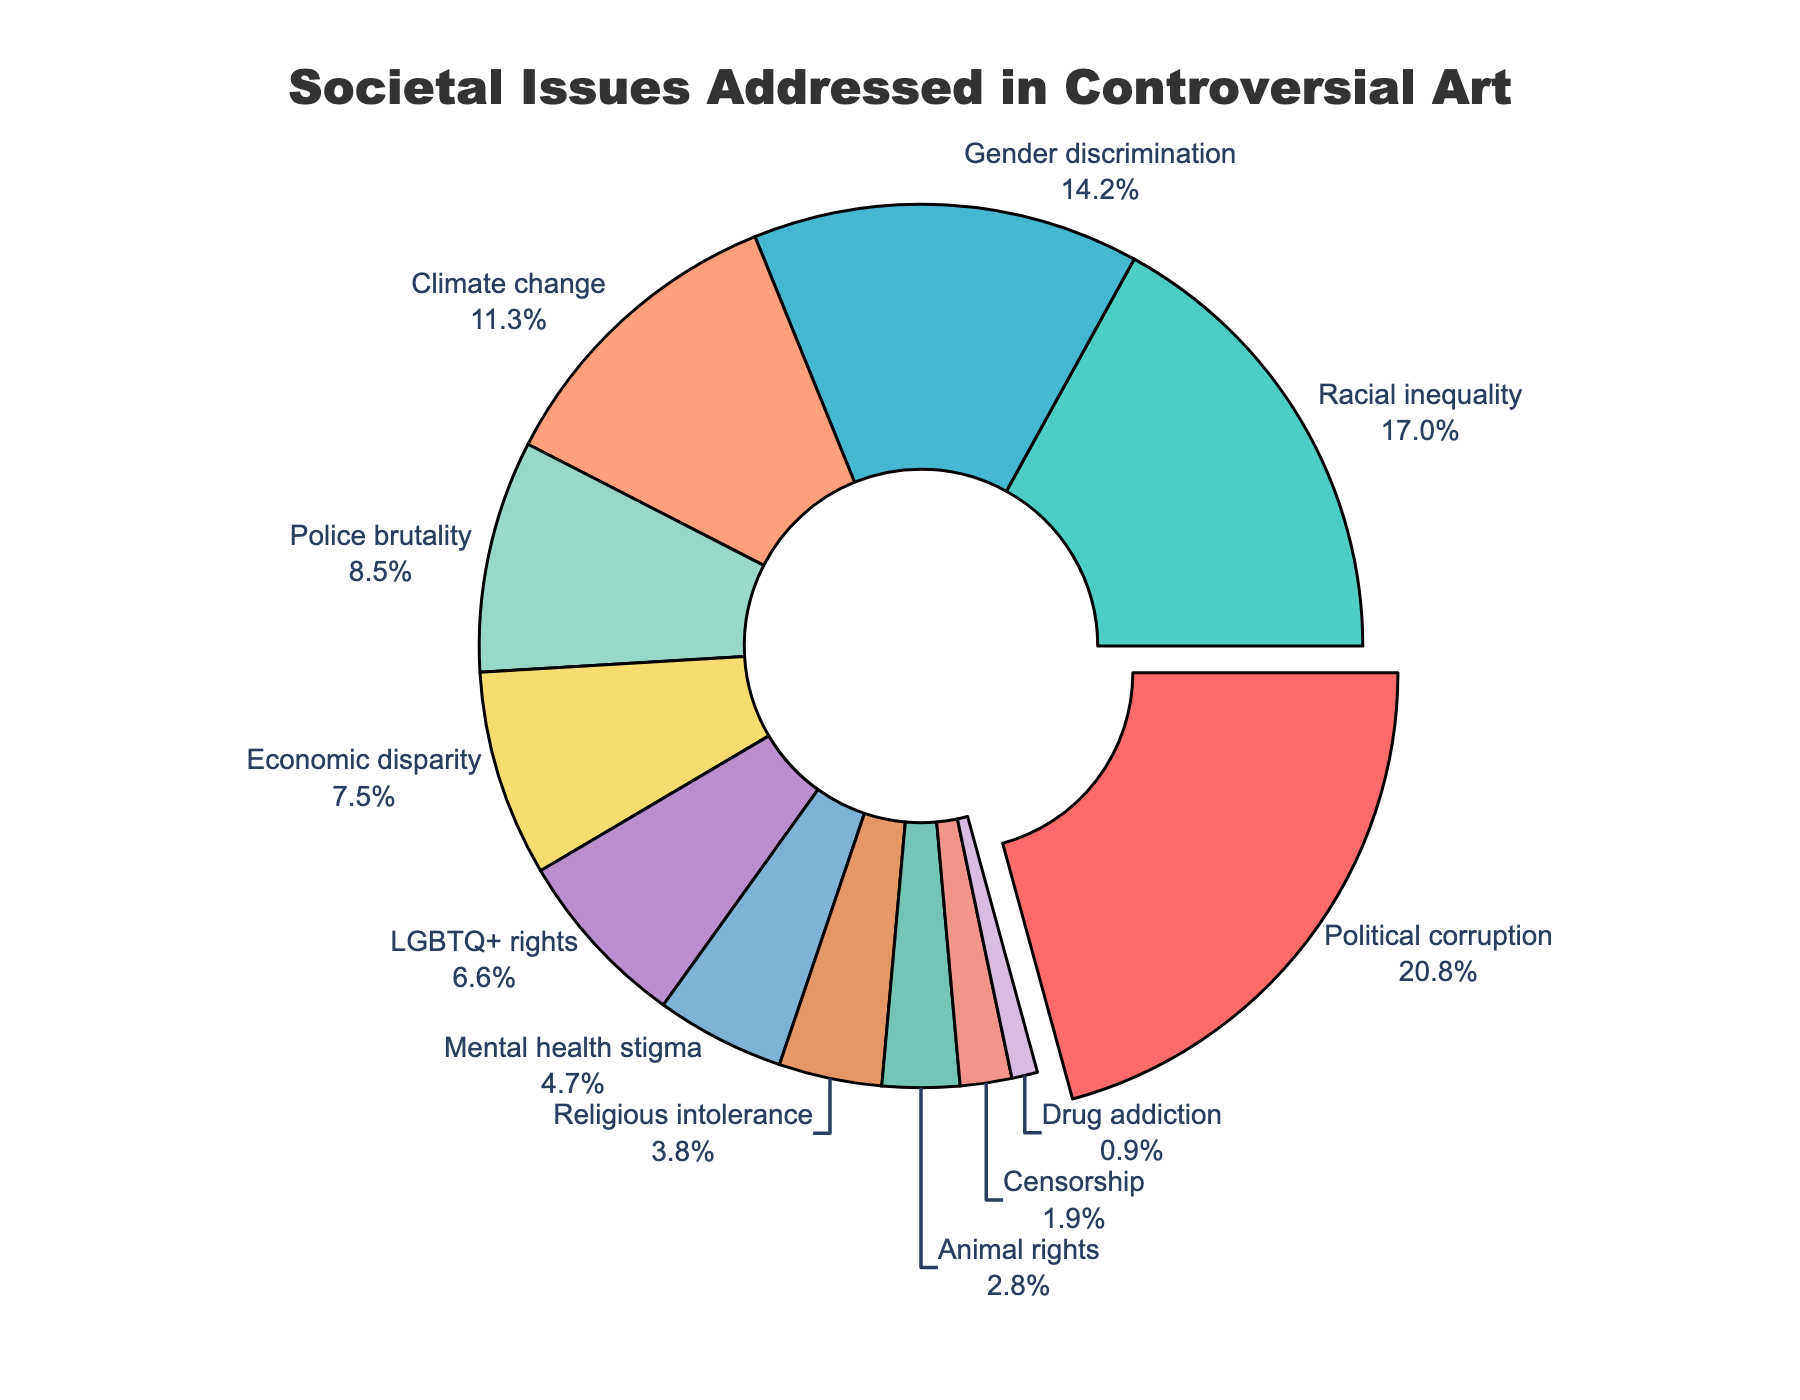What's the most addressed societal issue through controversial art? The figure shows a pie chart with various societal issues and their corresponding proportions. The largest segment is for 'Political corruption' at 22%.
Answer: Political corruption Which two issues together make up approximately one-third of the total proportion? Adding the percentages of 'Racial inequality' (18%) and 'Gender discrimination' (15%), we get 33%, which is approximately one-third of 100%.
Answer: Racial inequality and Gender discrimination How much more prominent is 'Political corruption' compared to 'LGBTQ+ rights'? 'Political corruption' has a percentage of 22%, while 'LGBTQ+ rights' has 7%. The difference is calculated as 22% - 7% = 15%.
Answer: 15% Which issue is least addressed through controversial art? The pie chart's smallest segment, with 1%, is 'Drug addiction'.
Answer: Drug addiction Are 'Mental health stigma' and 'Religious intolerance' addressed equally in controversial art? According to the pie chart, 'Mental health stigma' has a proportion of 5%, and 'Religious intolerance' has 4%. They are not equal, with 'Mental health stigma' being slightly higher.
Answer: No What is the combined proportion of issues related to discrimination (racial inequality, gender discrimination, LGBTQ+ rights)? Adding the percentages for 'Racial inequality' (18%), 'Gender discrimination' (15%), and 'LGBTQ+ rights' (7%) gives 18% + 15% + 7% = 40%.
Answer: 40% How does 'Animal rights' compare visually in the pie chart to 'Censorship'? 'Animal rights' occupies a larger segment compared to 'Censorship'. The percentage for 'Animal rights' is 3%, while for 'Censorship' is 2%.
Answer: 'Animal rights' is larger How does the prominence of 'Climate change' compare to 'Police brutality'? 'Climate change' has a percentage of 12%, while 'Police brutality' has 9%, making 'Climate change' more prominent by a difference of 3%.
Answer: Climate change is more prominent What percentage of the addressed issues are related to inequality (racial, gender, economic disparity)? Summing the percentages for 'Racial inequality' (18%), 'Gender discrimination' (15%), and 'Economic disparity' (8%) gives 18% + 15% + 8% = 41%.
Answer: 41% Is there a significant visual difference between the proportions of 'Mental health stigma' and 'Animal rights'? The proportion of 'Mental health stigma' is 5%, while 'Animal rights' is 3%. This represents a small difference of 2%, indicating a slight visual difference.
Answer: No significant visual difference 